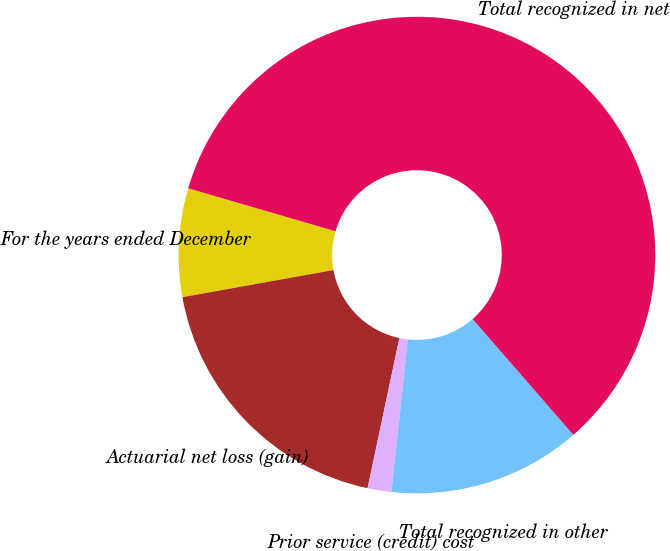<chart> <loc_0><loc_0><loc_500><loc_500><pie_chart><fcel>For the years ended December<fcel>Actuarial net loss (gain)<fcel>Prior service (credit) cost<fcel>Total recognized in other<fcel>Total recognized in net<nl><fcel>7.35%<fcel>18.85%<fcel>1.61%<fcel>13.1%<fcel>59.09%<nl></chart> 